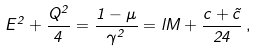<formula> <loc_0><loc_0><loc_500><loc_500>E ^ { 2 } + \frac { Q ^ { 2 } } { 4 } = \frac { 1 - \mu } { \gamma ^ { 2 } } = l M + \frac { c + \tilde { c } } { 2 4 } \, ,</formula> 